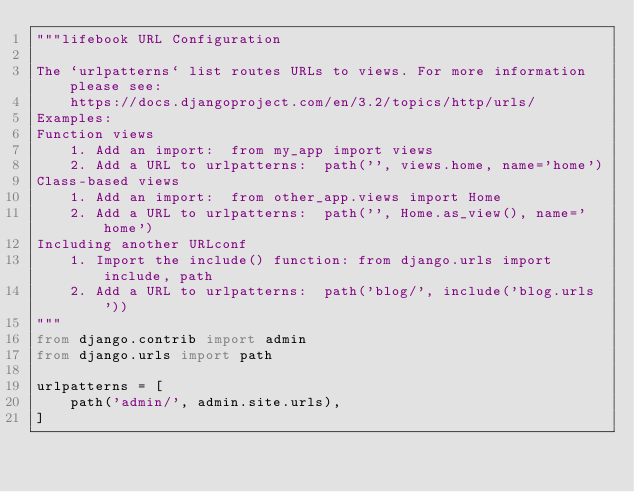<code> <loc_0><loc_0><loc_500><loc_500><_Python_>"""lifebook URL Configuration

The `urlpatterns` list routes URLs to views. For more information please see:
    https://docs.djangoproject.com/en/3.2/topics/http/urls/
Examples:
Function views
    1. Add an import:  from my_app import views
    2. Add a URL to urlpatterns:  path('', views.home, name='home')
Class-based views
    1. Add an import:  from other_app.views import Home
    2. Add a URL to urlpatterns:  path('', Home.as_view(), name='home')
Including another URLconf
    1. Import the include() function: from django.urls import include, path
    2. Add a URL to urlpatterns:  path('blog/', include('blog.urls'))
"""
from django.contrib import admin
from django.urls import path

urlpatterns = [
    path('admin/', admin.site.urls),
]
</code> 